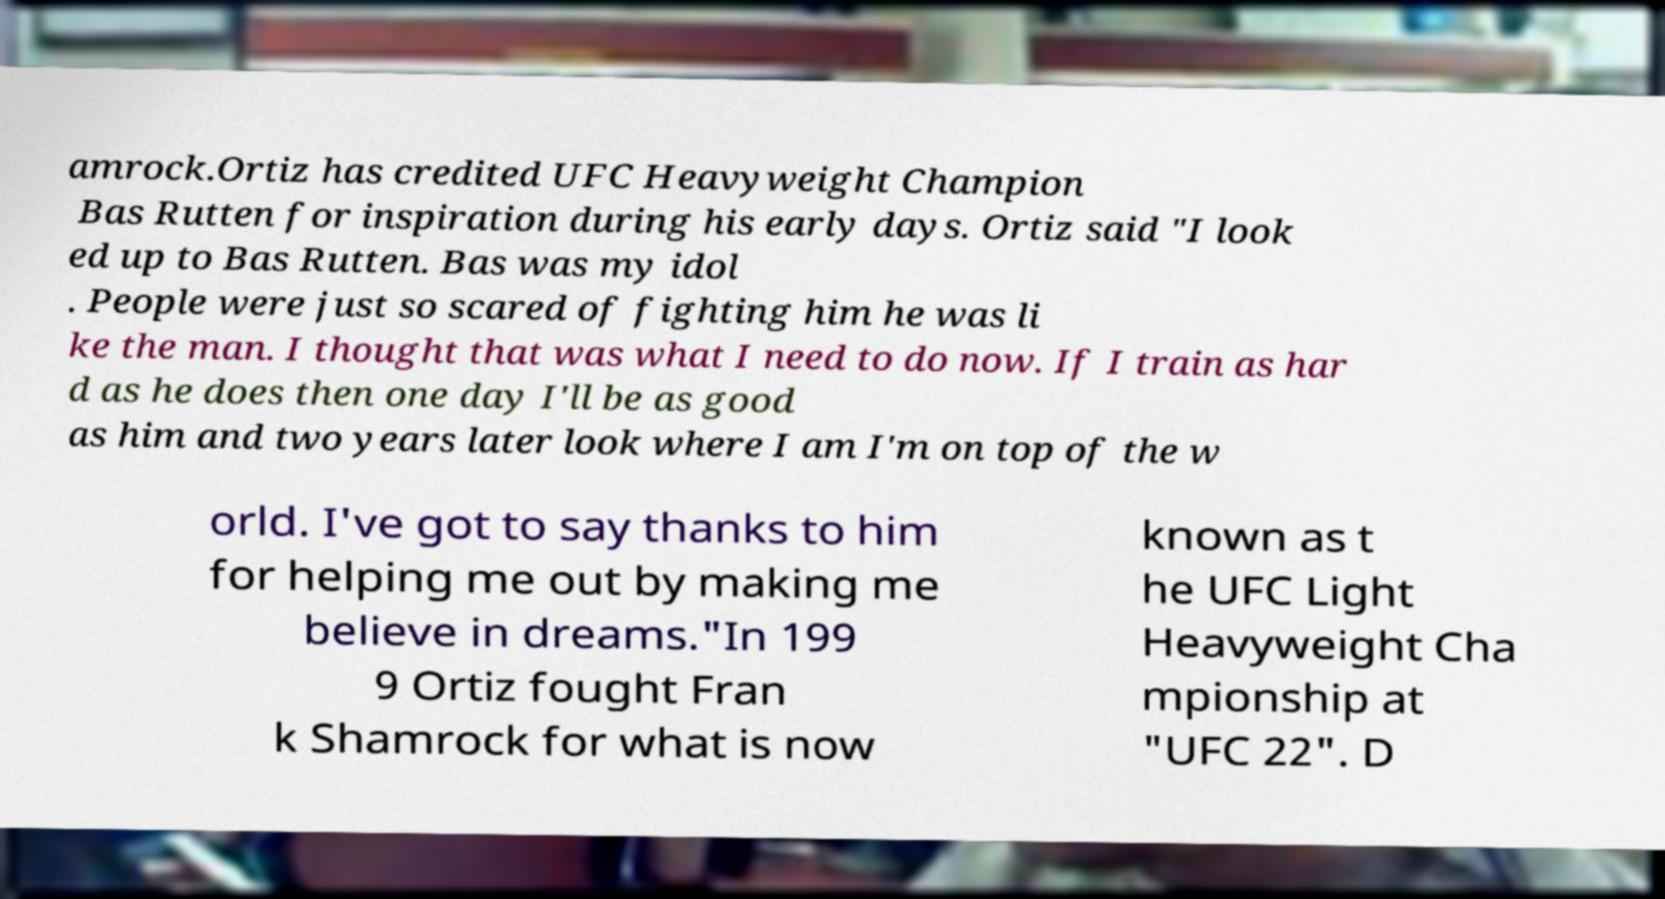For documentation purposes, I need the text within this image transcribed. Could you provide that? amrock.Ortiz has credited UFC Heavyweight Champion Bas Rutten for inspiration during his early days. Ortiz said "I look ed up to Bas Rutten. Bas was my idol . People were just so scared of fighting him he was li ke the man. I thought that was what I need to do now. If I train as har d as he does then one day I'll be as good as him and two years later look where I am I'm on top of the w orld. I've got to say thanks to him for helping me out by making me believe in dreams."In 199 9 Ortiz fought Fran k Shamrock for what is now known as t he UFC Light Heavyweight Cha mpionship at "UFC 22". D 